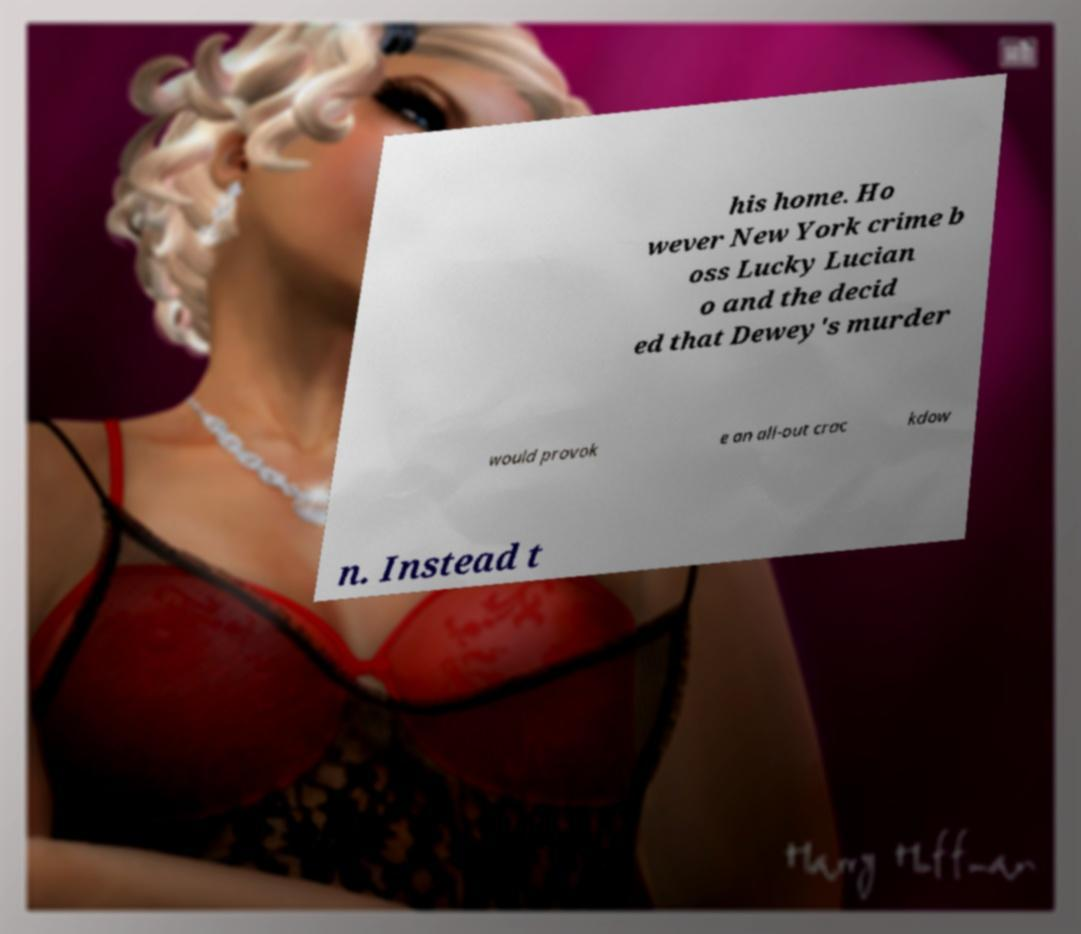Could you assist in decoding the text presented in this image and type it out clearly? his home. Ho wever New York crime b oss Lucky Lucian o and the decid ed that Dewey's murder would provok e an all-out crac kdow n. Instead t 